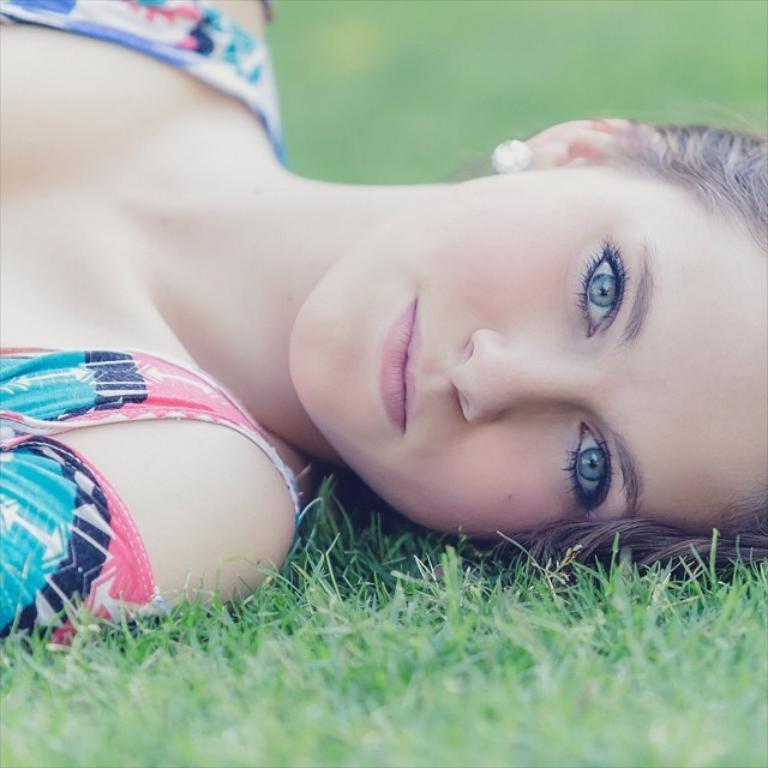Can you describe this image briefly? In this picture we can see a woman lying on the grass and smiling and in the background it is blurry. 